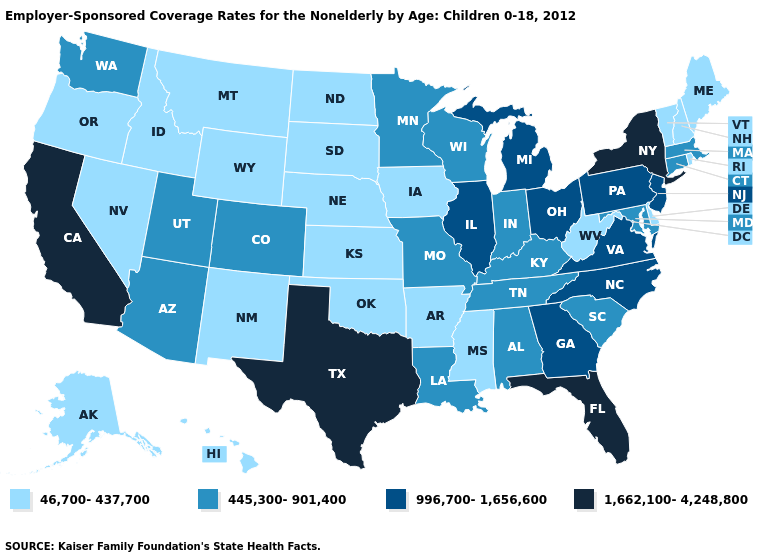What is the value of Nebraska?
Quick response, please. 46,700-437,700. What is the value of North Dakota?
Short answer required. 46,700-437,700. Which states hav the highest value in the Northeast?
Give a very brief answer. New York. Which states have the lowest value in the Northeast?
Write a very short answer. Maine, New Hampshire, Rhode Island, Vermont. Does Hawaii have the highest value in the USA?
Be succinct. No. Name the states that have a value in the range 445,300-901,400?
Quick response, please. Alabama, Arizona, Colorado, Connecticut, Indiana, Kentucky, Louisiana, Maryland, Massachusetts, Minnesota, Missouri, South Carolina, Tennessee, Utah, Washington, Wisconsin. Which states hav the highest value in the MidWest?
Be succinct. Illinois, Michigan, Ohio. Which states have the lowest value in the MidWest?
Quick response, please. Iowa, Kansas, Nebraska, North Dakota, South Dakota. Among the states that border Idaho , does Wyoming have the highest value?
Keep it brief. No. Does the first symbol in the legend represent the smallest category?
Answer briefly. Yes. Name the states that have a value in the range 996,700-1,656,600?
Concise answer only. Georgia, Illinois, Michigan, New Jersey, North Carolina, Ohio, Pennsylvania, Virginia. How many symbols are there in the legend?
Answer briefly. 4. Name the states that have a value in the range 46,700-437,700?
Write a very short answer. Alaska, Arkansas, Delaware, Hawaii, Idaho, Iowa, Kansas, Maine, Mississippi, Montana, Nebraska, Nevada, New Hampshire, New Mexico, North Dakota, Oklahoma, Oregon, Rhode Island, South Dakota, Vermont, West Virginia, Wyoming. What is the lowest value in the MidWest?
Keep it brief. 46,700-437,700. 